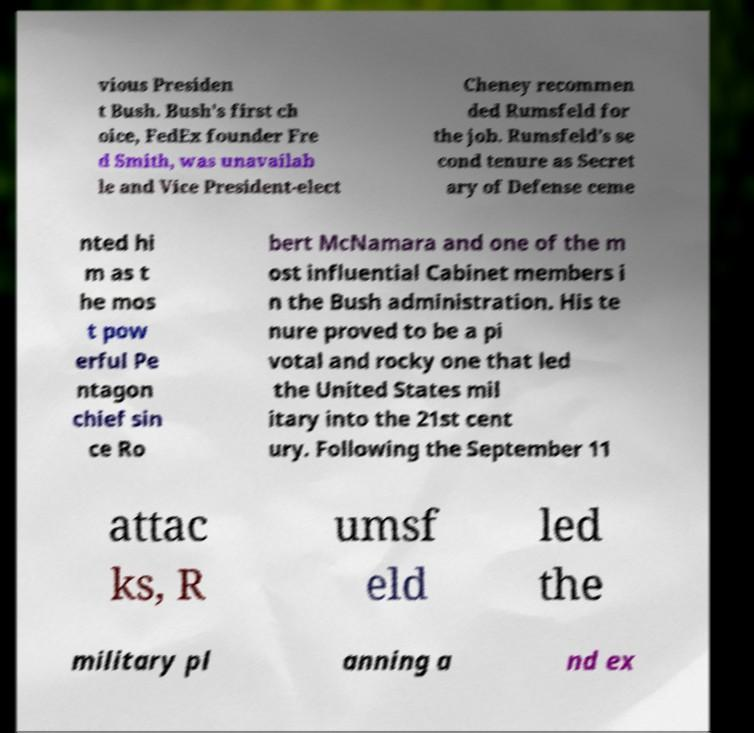Could you extract and type out the text from this image? vious Presiden t Bush. Bush's first ch oice, FedEx founder Fre d Smith, was unavailab le and Vice President-elect Cheney recommen ded Rumsfeld for the job. Rumsfeld's se cond tenure as Secret ary of Defense ceme nted hi m as t he mos t pow erful Pe ntagon chief sin ce Ro bert McNamara and one of the m ost influential Cabinet members i n the Bush administration. His te nure proved to be a pi votal and rocky one that led the United States mil itary into the 21st cent ury. Following the September 11 attac ks, R umsf eld led the military pl anning a nd ex 